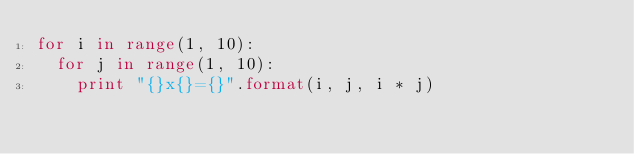Convert code to text. <code><loc_0><loc_0><loc_500><loc_500><_Python_>for i in range(1, 10):
  for j in range(1, 10):
    print "{}x{}={}".format(i, j, i * j)</code> 